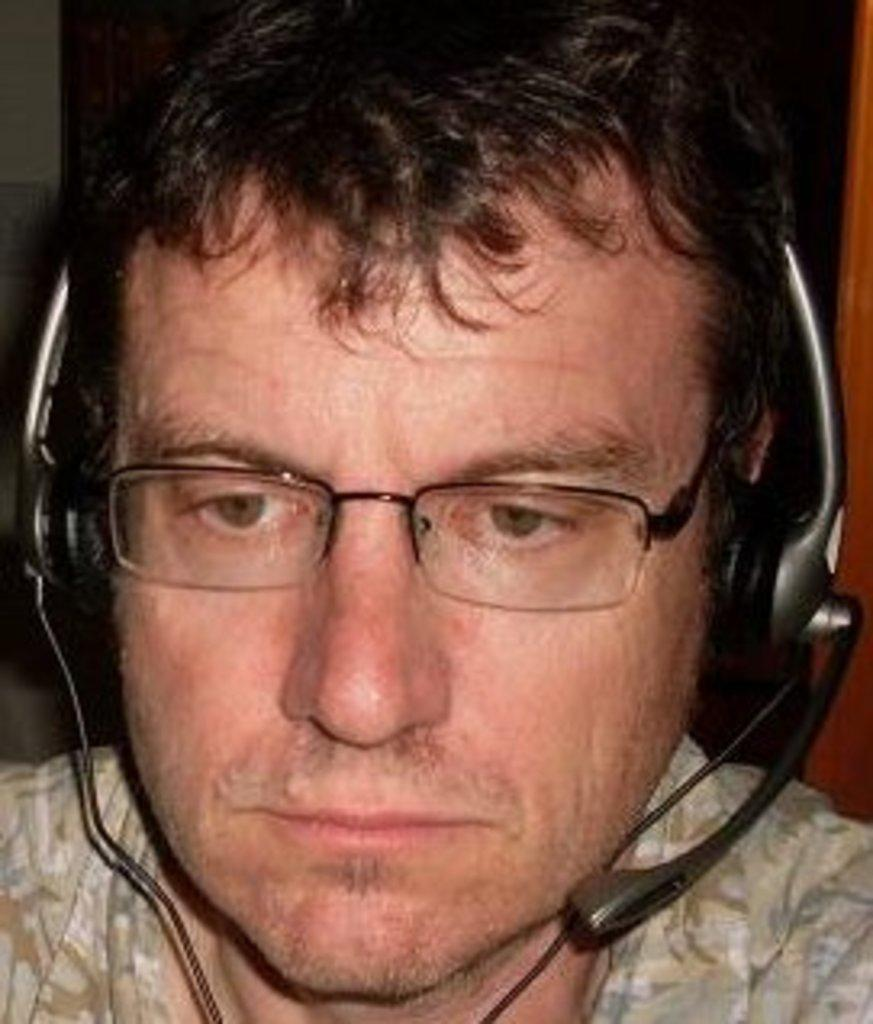What is the main subject of the image? There is a person in the center of the image. What can be observed about the person's appearance? The person is wearing spectacles and a headset. What type of zebra can be seen in the image? There is no zebra present in the image. How does the person taste the headset in the image? The person is not tasting the headset in the image; they are wearing it. 